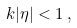Convert formula to latex. <formula><loc_0><loc_0><loc_500><loc_500>k | \eta | < 1 \, ,</formula> 